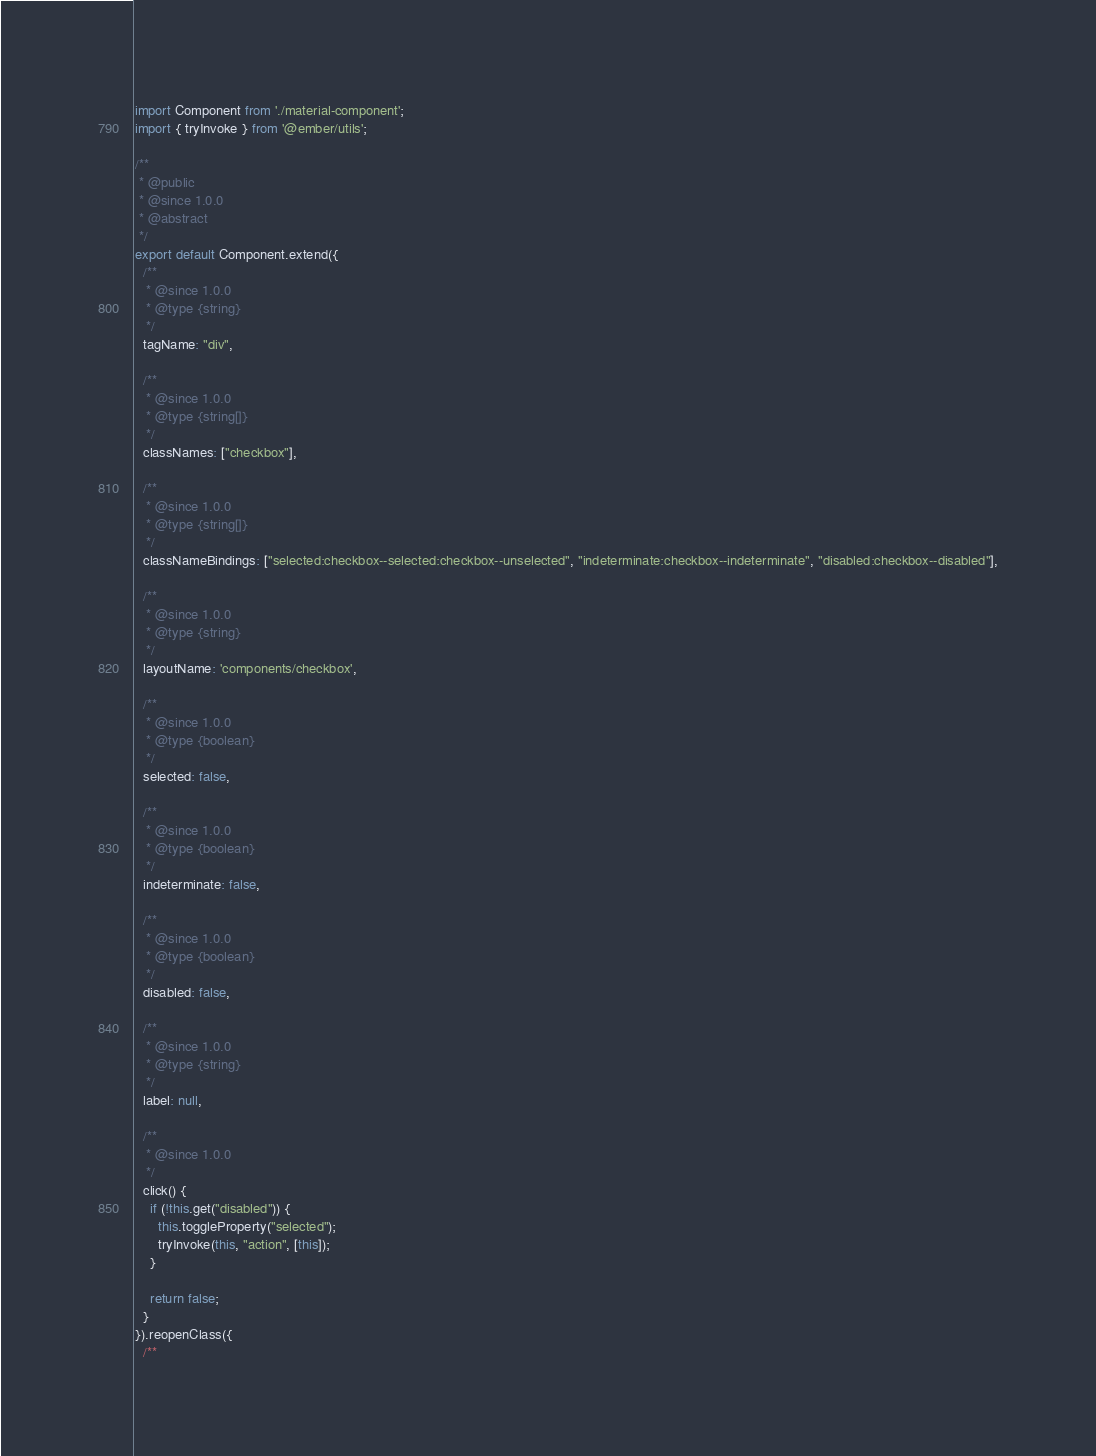Convert code to text. <code><loc_0><loc_0><loc_500><loc_500><_JavaScript_>import Component from './material-component';
import { tryInvoke } from '@ember/utils';

/**
 * @public
 * @since 1.0.0
 * @abstract
 */
export default Component.extend({
  /**
   * @since 1.0.0
   * @type {string}
   */
  tagName: "div",

  /**
   * @since 1.0.0
   * @type {string[]}
   */
  classNames: ["checkbox"],

  /**
   * @since 1.0.0
   * @type {string[]}
   */
  classNameBindings: ["selected:checkbox--selected:checkbox--unselected", "indeterminate:checkbox--indeterminate", "disabled:checkbox--disabled"],

  /**
   * @since 1.0.0
   * @type {string}
   */
  layoutName: 'components/checkbox',

  /**
   * @since 1.0.0
   * @type {boolean}
   */
  selected: false,

  /**
   * @since 1.0.0
   * @type {boolean}
   */
  indeterminate: false,

  /**
   * @since 1.0.0
   * @type {boolean}
   */
  disabled: false,

  /**
   * @since 1.0.0
   * @type {string}
   */
  label: null,

  /**
   * @since 1.0.0
   */
  click() {
    if (!this.get("disabled")) {
      this.toggleProperty("selected");
      tryInvoke(this, "action", [this]);
    }

    return false;
  }
}).reopenClass({
  /**</code> 